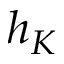<formula> <loc_0><loc_0><loc_500><loc_500>h _ { K }</formula> 